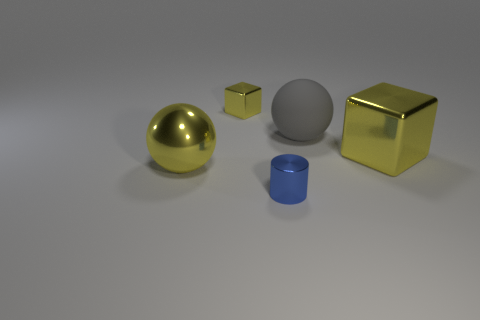Add 4 big purple rubber blocks. How many objects exist? 9 Subtract all yellow spheres. How many spheres are left? 1 Subtract all balls. How many objects are left? 3 Subtract 1 cylinders. How many cylinders are left? 0 Subtract all blue balls. Subtract all blue cylinders. How many balls are left? 2 Subtract all big rubber spheres. Subtract all blue metallic objects. How many objects are left? 3 Add 4 gray balls. How many gray balls are left? 5 Add 4 balls. How many balls exist? 6 Subtract 0 cyan balls. How many objects are left? 5 